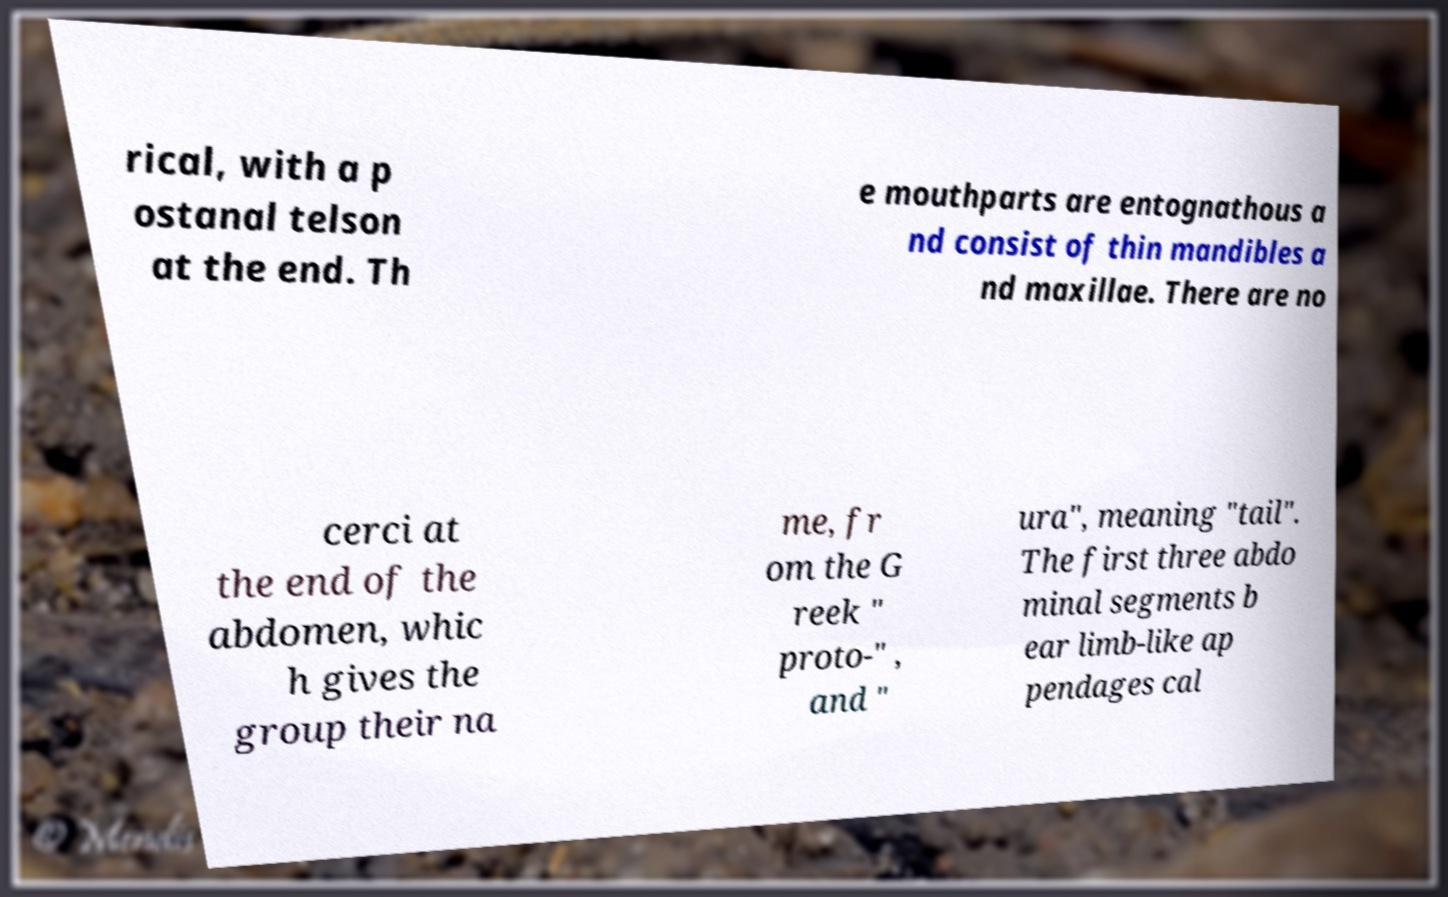Can you accurately transcribe the text from the provided image for me? rical, with a p ostanal telson at the end. Th e mouthparts are entognathous a nd consist of thin mandibles a nd maxillae. There are no cerci at the end of the abdomen, whic h gives the group their na me, fr om the G reek " proto-" , and " ura", meaning "tail". The first three abdo minal segments b ear limb-like ap pendages cal 